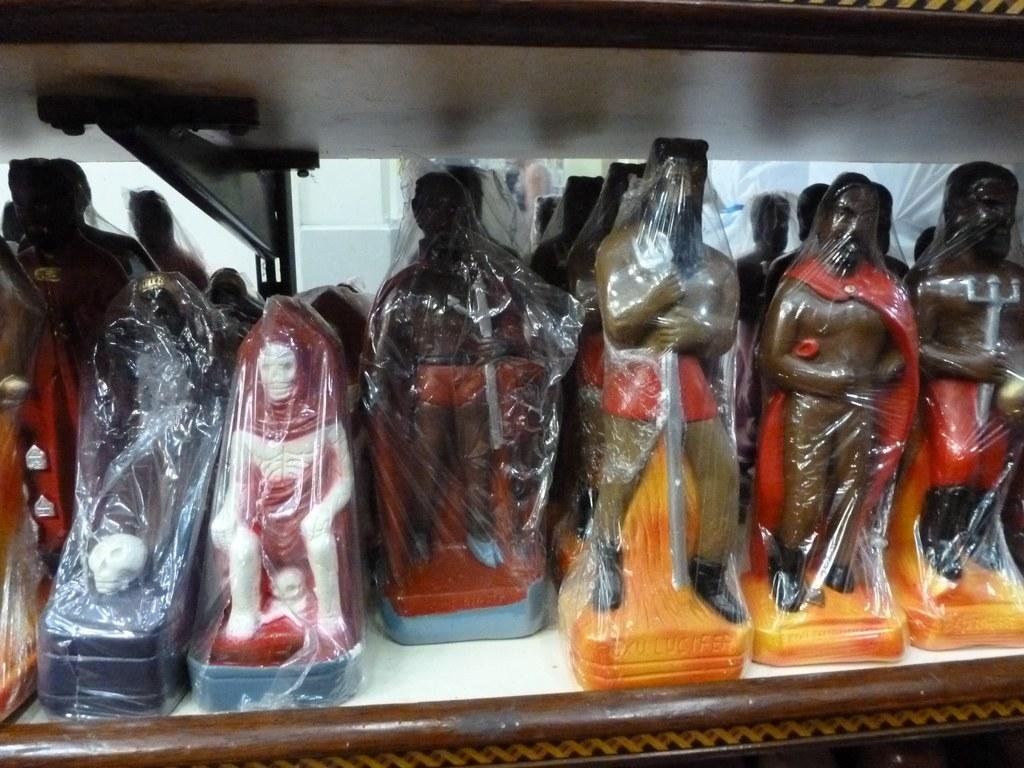What is present in the self in the image? There are many toys in the self. Can you describe the types of toys in the self? The specific types of toys cannot be determined from the image, but they are numerous and fill the self. What might be the purpose of having so many toys in the self? The purpose of having so many toys in the self could be for storage, organization, or display. What sorting apparatus is being used to organize the toys in the image? There is no sorting apparatus visible in the image; the toys are simply stored in the self. How does the self in the image help improve memory? The self in the image does not directly improve memory; it is a storage container for toys. 